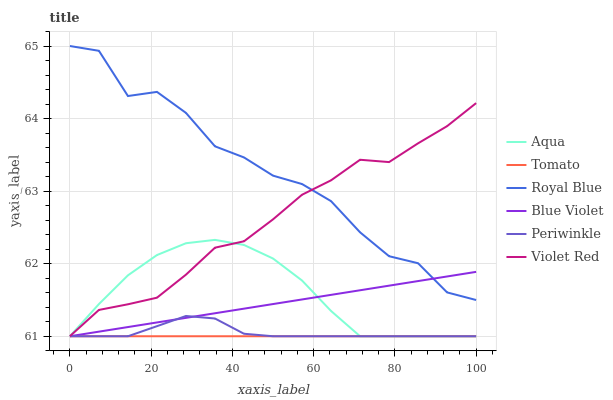Does Tomato have the minimum area under the curve?
Answer yes or no. Yes. Does Royal Blue have the maximum area under the curve?
Answer yes or no. Yes. Does Violet Red have the minimum area under the curve?
Answer yes or no. No. Does Violet Red have the maximum area under the curve?
Answer yes or no. No. Is Tomato the smoothest?
Answer yes or no. Yes. Is Royal Blue the roughest?
Answer yes or no. Yes. Is Violet Red the smoothest?
Answer yes or no. No. Is Violet Red the roughest?
Answer yes or no. No. Does Tomato have the lowest value?
Answer yes or no. Yes. Does Violet Red have the lowest value?
Answer yes or no. No. Does Royal Blue have the highest value?
Answer yes or no. Yes. Does Violet Red have the highest value?
Answer yes or no. No. Is Tomato less than Royal Blue?
Answer yes or no. Yes. Is Royal Blue greater than Tomato?
Answer yes or no. Yes. Does Royal Blue intersect Blue Violet?
Answer yes or no. Yes. Is Royal Blue less than Blue Violet?
Answer yes or no. No. Is Royal Blue greater than Blue Violet?
Answer yes or no. No. Does Tomato intersect Royal Blue?
Answer yes or no. No. 